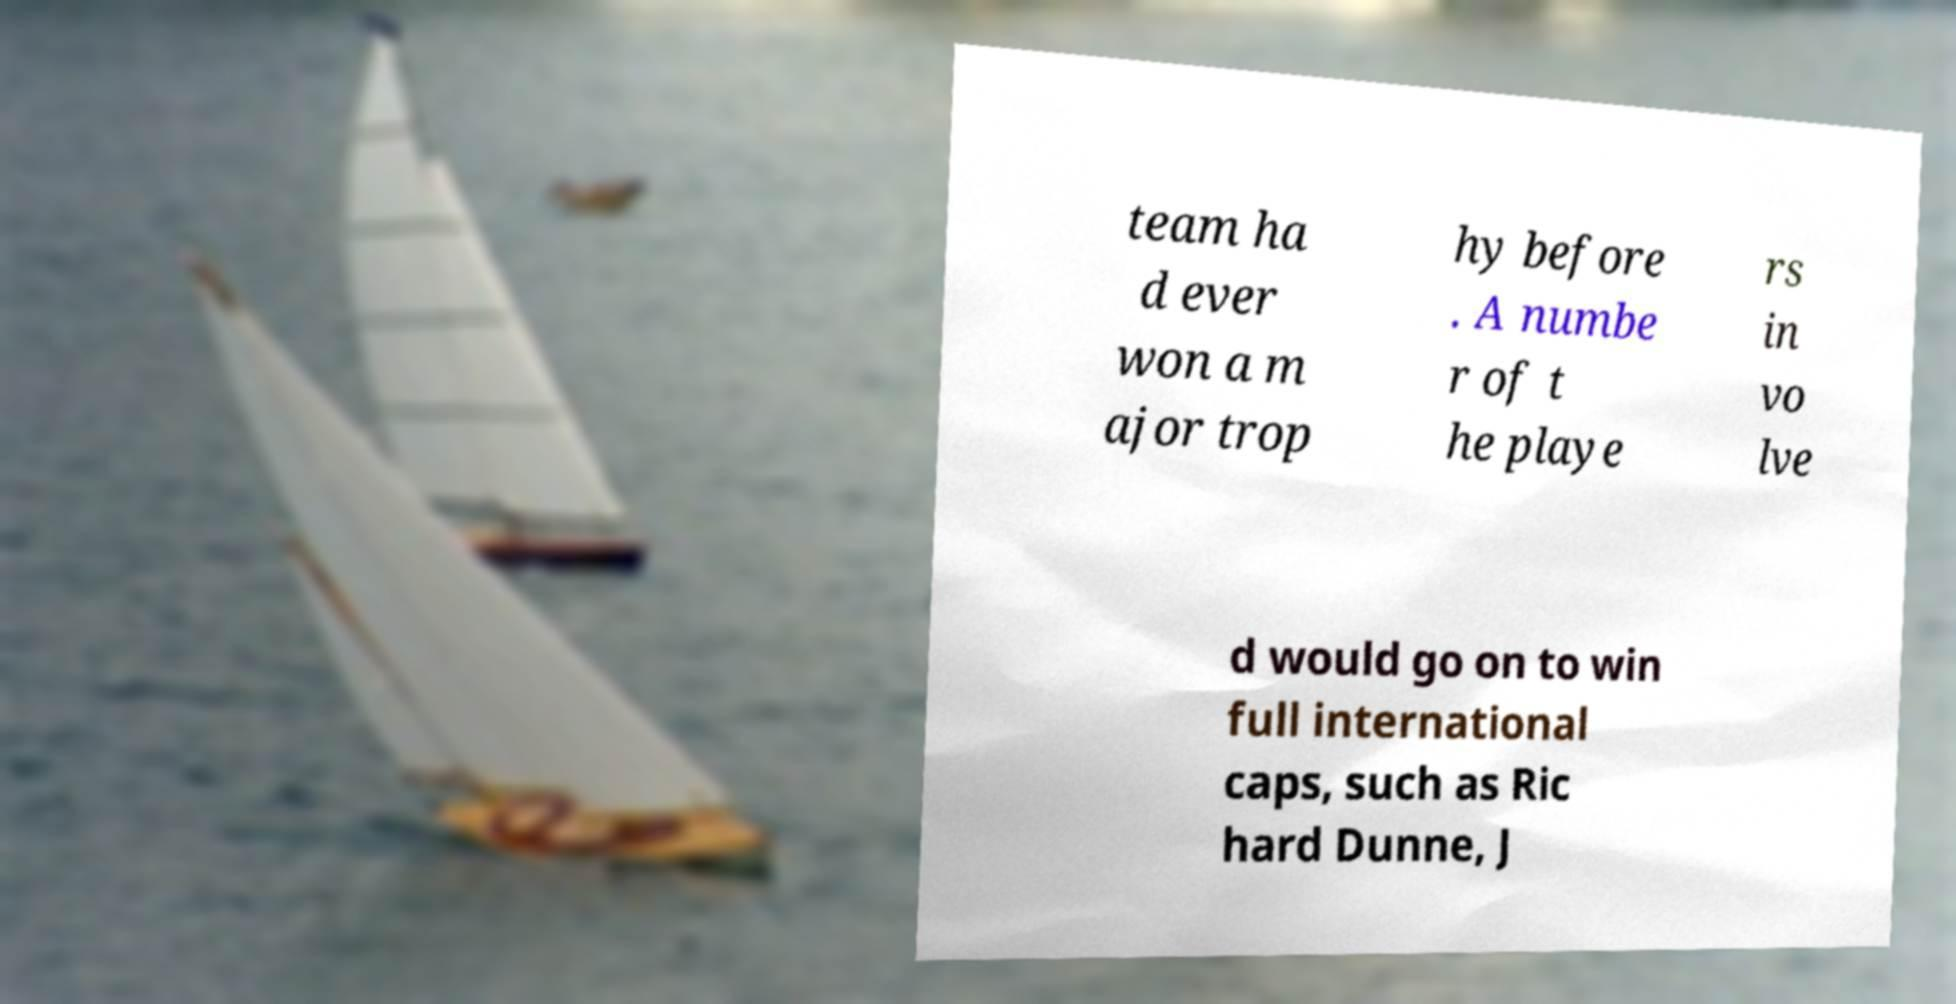Can you accurately transcribe the text from the provided image for me? team ha d ever won a m ajor trop hy before . A numbe r of t he playe rs in vo lve d would go on to win full international caps, such as Ric hard Dunne, J 